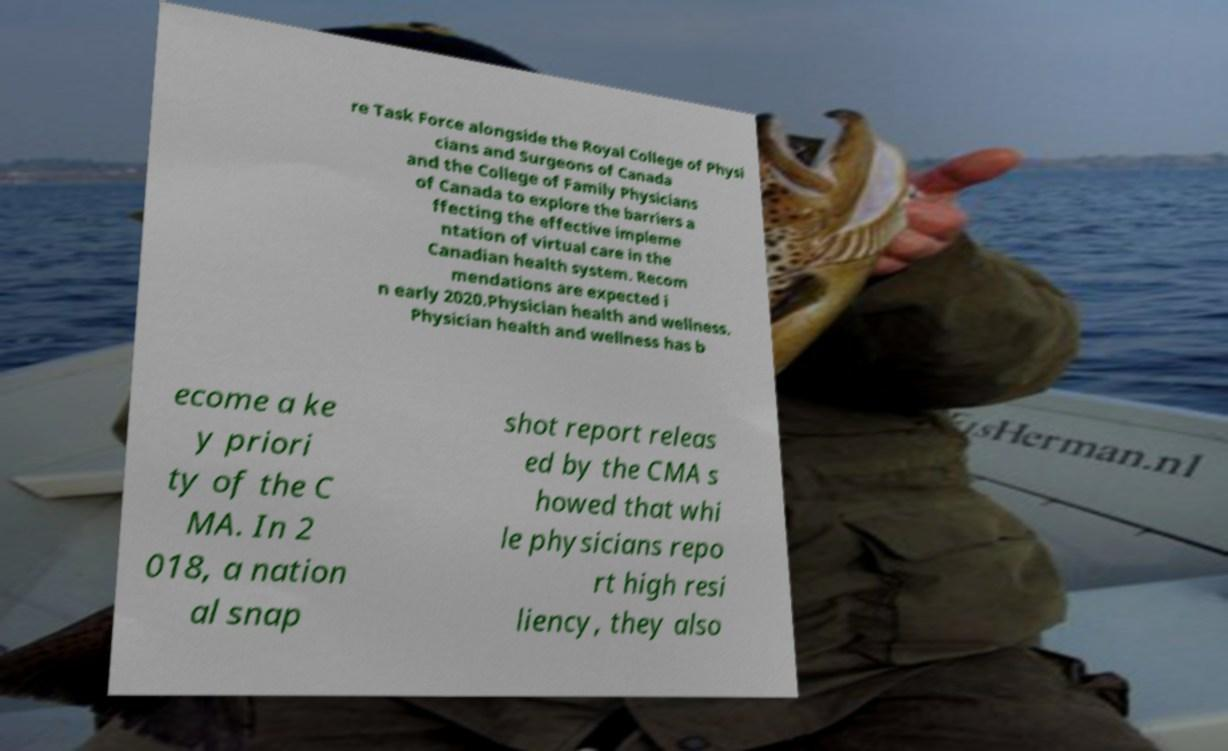Please read and relay the text visible in this image. What does it say? re Task Force alongside the Royal College of Physi cians and Surgeons of Canada and the College of Family Physicians of Canada to explore the barriers a ffecting the effective impleme ntation of virtual care in the Canadian health system. Recom mendations are expected i n early 2020.Physician health and wellness. Physician health and wellness has b ecome a ke y priori ty of the C MA. In 2 018, a nation al snap shot report releas ed by the CMA s howed that whi le physicians repo rt high resi liency, they also 